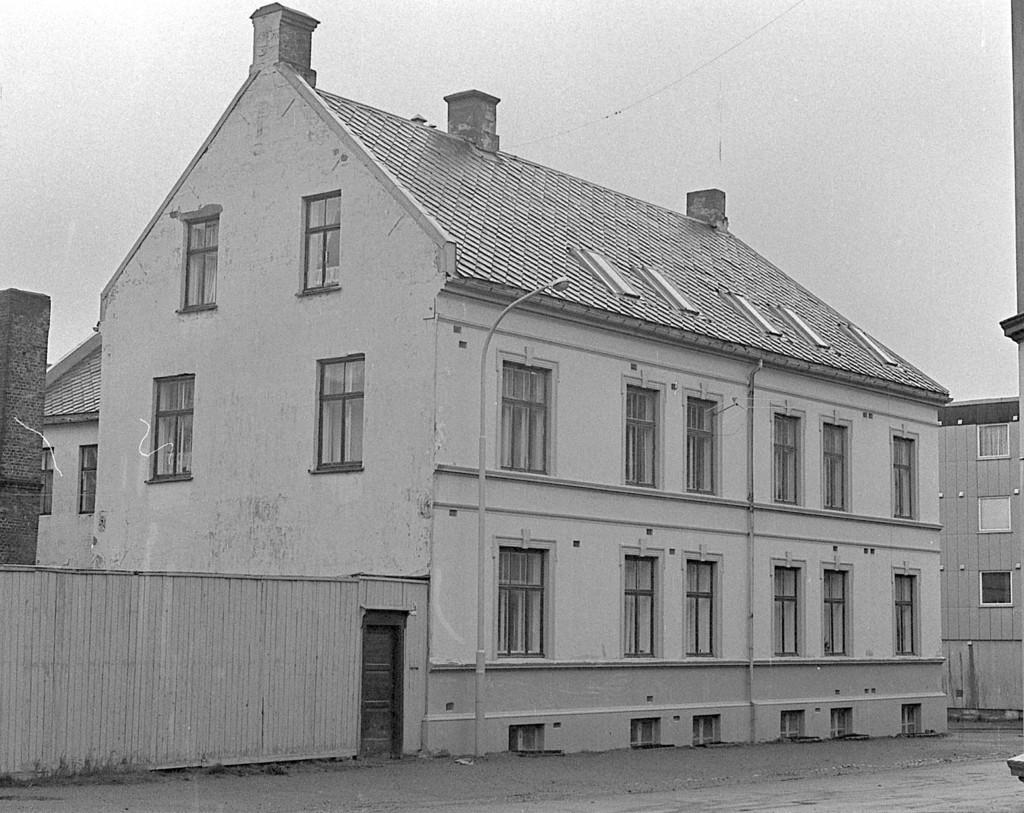Please provide a concise description of this image. In this image there are buildings, light poles. On the left side of the image there is a closed door. There is a wall. At the top of the image there is sky. 